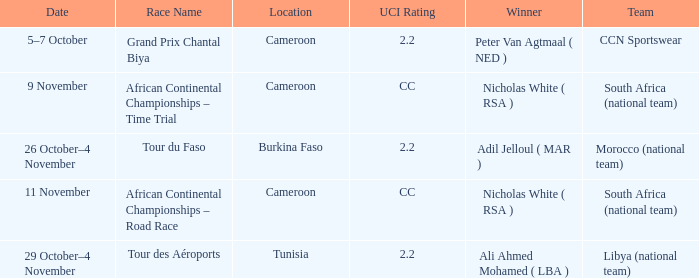What is the location of the race on 11 November? Cameroon. 